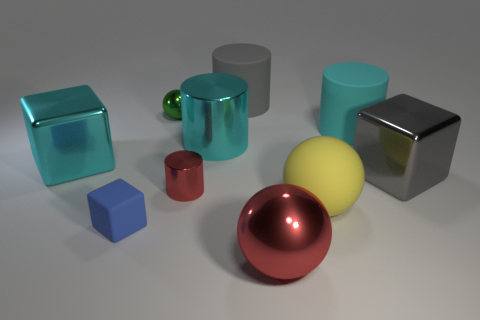Are there any other things that have the same shape as the small red thing?
Offer a very short reply. Yes. The cyan metallic thing on the right side of the red object that is behind the large red object is what shape?
Provide a succinct answer. Cylinder. There is a small object that is made of the same material as the tiny cylinder; what shape is it?
Your response must be concise. Sphere. How big is the gray thing in front of the large gray thing that is left of the gray metal object?
Make the answer very short. Large. There is a yellow object; what shape is it?
Your answer should be very brief. Sphere. What number of tiny things are either cyan blocks or cylinders?
Your answer should be compact. 1. There is a green object that is the same shape as the yellow matte object; what size is it?
Your answer should be compact. Small. How many large rubber cylinders are both left of the red metallic ball and in front of the green object?
Make the answer very short. 0. There is a small blue rubber object; is it the same shape as the large gray object on the right side of the red ball?
Your response must be concise. Yes. Is the number of balls that are on the left side of the red shiny cylinder greater than the number of large green balls?
Ensure brevity in your answer.  Yes. 